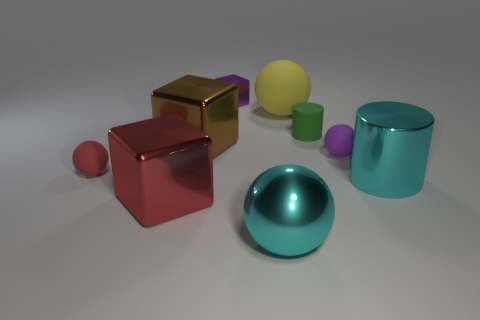There is a tiny purple object that is the same shape as the large rubber thing; what is it made of?
Keep it short and to the point. Rubber. What number of other objects are there of the same size as the cyan metallic ball?
Provide a short and direct response. 4. Are there any other things of the same color as the tiny rubber cylinder?
Make the answer very short. No. Is the color of the large matte object the same as the big cylinder?
Provide a succinct answer. No. Do the large thing behind the large brown block and the tiny cylinder that is behind the cyan metallic ball have the same material?
Give a very brief answer. Yes. How many things are either tiny purple things or spheres to the right of the red cube?
Offer a terse response. 4. There is a small rubber object that is the same color as the small cube; what shape is it?
Your answer should be very brief. Sphere. What is the material of the brown thing?
Your answer should be compact. Metal. Does the tiny green cylinder have the same material as the yellow ball?
Offer a terse response. Yes. What number of rubber things are either tiny gray cubes or big things?
Give a very brief answer. 1. 